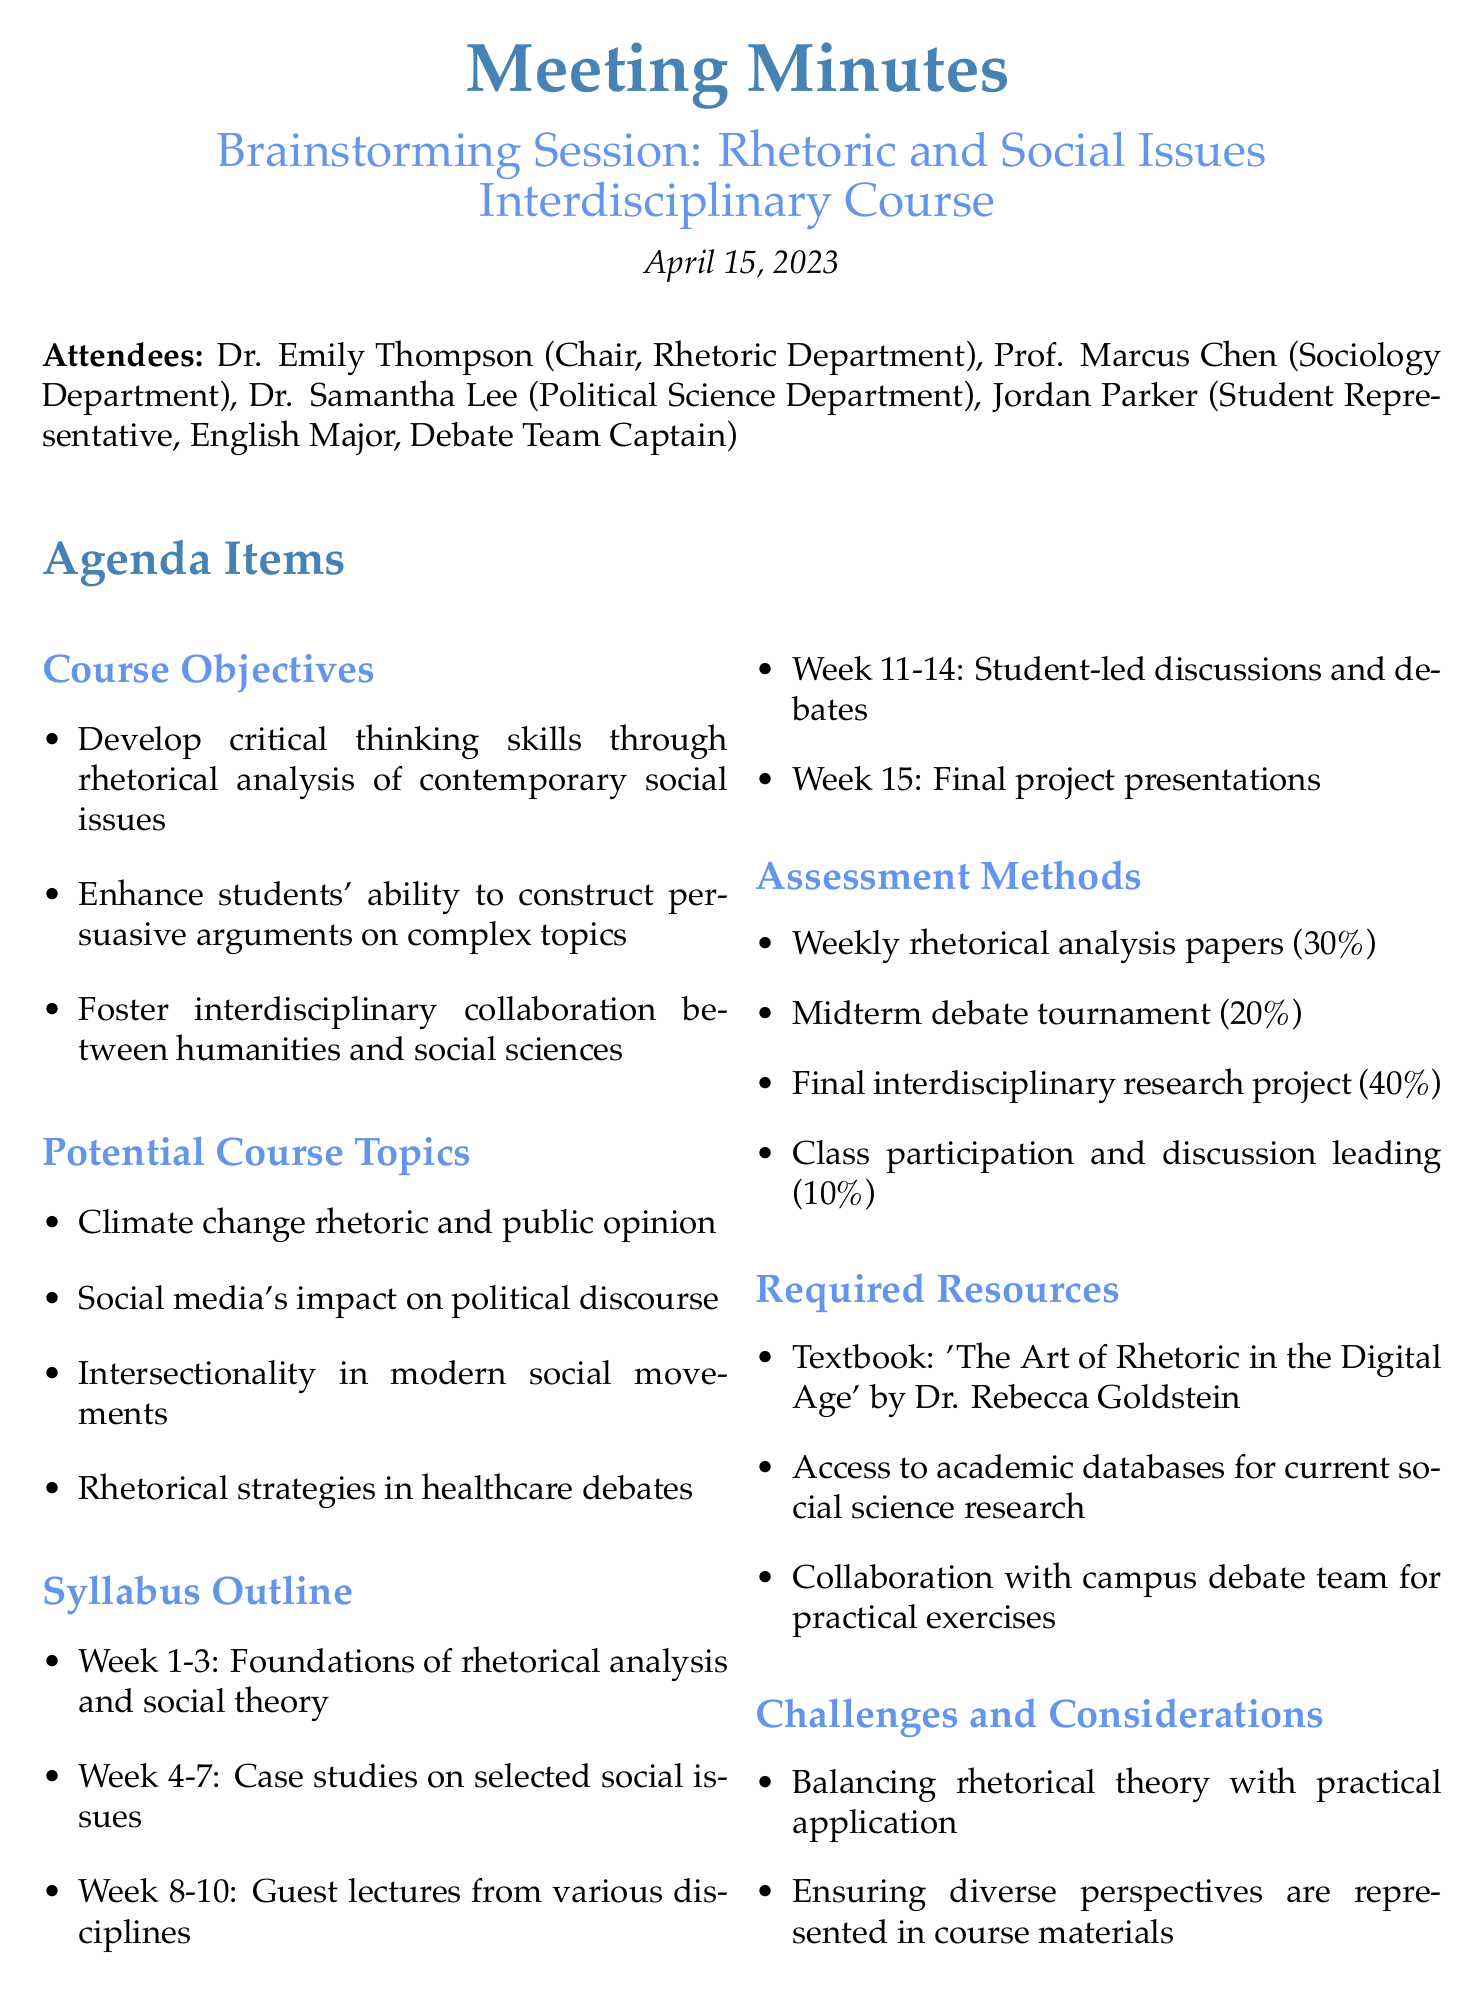What is the date of the meeting? The date of the meeting is listed in the document, which states "April 15, 2023."
Answer: April 15, 2023 Who is the chair of the Rhetoric Department? The chair of the Rhetoric Department is mentioned in the attendees list as "Dr. Emily Thompson."
Answer: Dr. Emily Thompson What percentage of the final grade is the midterm debate tournament? The assessment methods section specifies that the midterm debate tournament accounts for "20%."
Answer: 20% What is the title of the required textbook? The required resources section includes the title of the textbook, which is "The Art of Rhetoric in the Digital Age."
Answer: The Art of Rhetoric in the Digital Age What is one of the challenges mentioned in the document? The challenges and considerations section lists several points; one of them is "Balancing rhetorical theory with practical application."
Answer: Balancing rhetorical theory with practical application How many weeks are dedicated to student-led discussions and debates? The syllabus outline specifies that student-led discussions and debates span "Week 11-14," which is four weeks.
Answer: 4 weeks Which attendee represents the student body? The attendees section identifies the student representative as "Jordan Parker."
Answer: Jordan Parker 